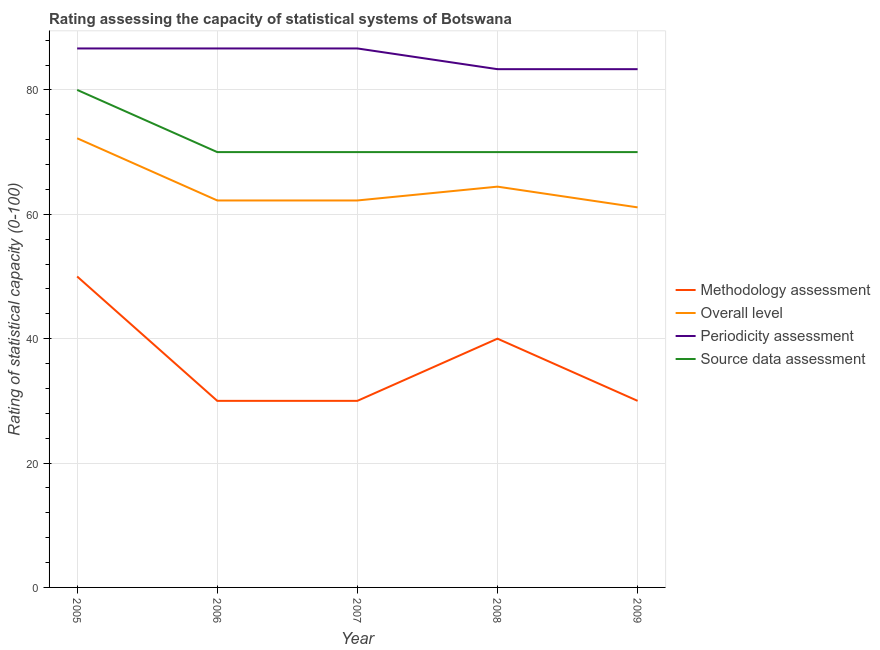Is the number of lines equal to the number of legend labels?
Your response must be concise. Yes. What is the source data assessment rating in 2008?
Give a very brief answer. 70. Across all years, what is the maximum overall level rating?
Your response must be concise. 72.22. Across all years, what is the minimum source data assessment rating?
Your answer should be compact. 70. In which year was the methodology assessment rating maximum?
Offer a terse response. 2005. In which year was the periodicity assessment rating minimum?
Keep it short and to the point. 2008. What is the total methodology assessment rating in the graph?
Make the answer very short. 180. What is the difference between the overall level rating in 2007 and that in 2008?
Keep it short and to the point. -2.22. What is the difference between the periodicity assessment rating in 2007 and the overall level rating in 2008?
Provide a short and direct response. 22.22. What is the average periodicity assessment rating per year?
Ensure brevity in your answer.  85.33. In the year 2008, what is the difference between the overall level rating and periodicity assessment rating?
Your response must be concise. -18.89. What is the ratio of the overall level rating in 2007 to that in 2008?
Your answer should be compact. 0.97. Is the source data assessment rating in 2006 less than that in 2008?
Keep it short and to the point. No. What is the difference between the highest and the second highest overall level rating?
Your answer should be very brief. 7.78. What is the difference between the highest and the lowest overall level rating?
Your answer should be very brief. 11.11. Is the sum of the overall level rating in 2008 and 2009 greater than the maximum periodicity assessment rating across all years?
Your answer should be very brief. Yes. Is it the case that in every year, the sum of the overall level rating and source data assessment rating is greater than the sum of methodology assessment rating and periodicity assessment rating?
Offer a very short reply. No. Is it the case that in every year, the sum of the methodology assessment rating and overall level rating is greater than the periodicity assessment rating?
Provide a succinct answer. Yes. How many years are there in the graph?
Provide a succinct answer. 5. What is the difference between two consecutive major ticks on the Y-axis?
Keep it short and to the point. 20. Are the values on the major ticks of Y-axis written in scientific E-notation?
Provide a succinct answer. No. Does the graph contain grids?
Offer a very short reply. Yes. Where does the legend appear in the graph?
Your answer should be very brief. Center right. How are the legend labels stacked?
Your answer should be compact. Vertical. What is the title of the graph?
Keep it short and to the point. Rating assessing the capacity of statistical systems of Botswana. What is the label or title of the Y-axis?
Your answer should be very brief. Rating of statistical capacity (0-100). What is the Rating of statistical capacity (0-100) in Methodology assessment in 2005?
Give a very brief answer. 50. What is the Rating of statistical capacity (0-100) of Overall level in 2005?
Your answer should be compact. 72.22. What is the Rating of statistical capacity (0-100) of Periodicity assessment in 2005?
Make the answer very short. 86.67. What is the Rating of statistical capacity (0-100) in Methodology assessment in 2006?
Provide a short and direct response. 30. What is the Rating of statistical capacity (0-100) in Overall level in 2006?
Your answer should be compact. 62.22. What is the Rating of statistical capacity (0-100) in Periodicity assessment in 2006?
Offer a very short reply. 86.67. What is the Rating of statistical capacity (0-100) of Methodology assessment in 2007?
Give a very brief answer. 30. What is the Rating of statistical capacity (0-100) of Overall level in 2007?
Provide a succinct answer. 62.22. What is the Rating of statistical capacity (0-100) in Periodicity assessment in 2007?
Provide a succinct answer. 86.67. What is the Rating of statistical capacity (0-100) in Source data assessment in 2007?
Provide a succinct answer. 70. What is the Rating of statistical capacity (0-100) in Overall level in 2008?
Keep it short and to the point. 64.44. What is the Rating of statistical capacity (0-100) in Periodicity assessment in 2008?
Offer a very short reply. 83.33. What is the Rating of statistical capacity (0-100) in Overall level in 2009?
Keep it short and to the point. 61.11. What is the Rating of statistical capacity (0-100) in Periodicity assessment in 2009?
Provide a short and direct response. 83.33. Across all years, what is the maximum Rating of statistical capacity (0-100) in Overall level?
Give a very brief answer. 72.22. Across all years, what is the maximum Rating of statistical capacity (0-100) of Periodicity assessment?
Provide a succinct answer. 86.67. Across all years, what is the maximum Rating of statistical capacity (0-100) in Source data assessment?
Make the answer very short. 80. Across all years, what is the minimum Rating of statistical capacity (0-100) of Overall level?
Offer a very short reply. 61.11. Across all years, what is the minimum Rating of statistical capacity (0-100) in Periodicity assessment?
Provide a succinct answer. 83.33. Across all years, what is the minimum Rating of statistical capacity (0-100) of Source data assessment?
Provide a short and direct response. 70. What is the total Rating of statistical capacity (0-100) in Methodology assessment in the graph?
Give a very brief answer. 180. What is the total Rating of statistical capacity (0-100) in Overall level in the graph?
Your answer should be compact. 322.22. What is the total Rating of statistical capacity (0-100) in Periodicity assessment in the graph?
Offer a terse response. 426.67. What is the total Rating of statistical capacity (0-100) of Source data assessment in the graph?
Keep it short and to the point. 360. What is the difference between the Rating of statistical capacity (0-100) of Overall level in 2005 and that in 2006?
Ensure brevity in your answer.  10. What is the difference between the Rating of statistical capacity (0-100) in Periodicity assessment in 2005 and that in 2006?
Ensure brevity in your answer.  0. What is the difference between the Rating of statistical capacity (0-100) of Periodicity assessment in 2005 and that in 2007?
Keep it short and to the point. 0. What is the difference between the Rating of statistical capacity (0-100) of Source data assessment in 2005 and that in 2007?
Your answer should be compact. 10. What is the difference between the Rating of statistical capacity (0-100) of Overall level in 2005 and that in 2008?
Your answer should be compact. 7.78. What is the difference between the Rating of statistical capacity (0-100) of Periodicity assessment in 2005 and that in 2008?
Make the answer very short. 3.33. What is the difference between the Rating of statistical capacity (0-100) in Source data assessment in 2005 and that in 2008?
Ensure brevity in your answer.  10. What is the difference between the Rating of statistical capacity (0-100) of Methodology assessment in 2005 and that in 2009?
Your response must be concise. 20. What is the difference between the Rating of statistical capacity (0-100) of Overall level in 2005 and that in 2009?
Make the answer very short. 11.11. What is the difference between the Rating of statistical capacity (0-100) of Periodicity assessment in 2005 and that in 2009?
Make the answer very short. 3.33. What is the difference between the Rating of statistical capacity (0-100) in Source data assessment in 2006 and that in 2007?
Make the answer very short. 0. What is the difference between the Rating of statistical capacity (0-100) in Overall level in 2006 and that in 2008?
Your answer should be very brief. -2.22. What is the difference between the Rating of statistical capacity (0-100) of Periodicity assessment in 2006 and that in 2008?
Your response must be concise. 3.33. What is the difference between the Rating of statistical capacity (0-100) of Source data assessment in 2006 and that in 2008?
Provide a succinct answer. 0. What is the difference between the Rating of statistical capacity (0-100) of Methodology assessment in 2006 and that in 2009?
Offer a terse response. 0. What is the difference between the Rating of statistical capacity (0-100) of Overall level in 2006 and that in 2009?
Keep it short and to the point. 1.11. What is the difference between the Rating of statistical capacity (0-100) in Periodicity assessment in 2006 and that in 2009?
Keep it short and to the point. 3.33. What is the difference between the Rating of statistical capacity (0-100) in Overall level in 2007 and that in 2008?
Your response must be concise. -2.22. What is the difference between the Rating of statistical capacity (0-100) of Source data assessment in 2007 and that in 2008?
Offer a terse response. 0. What is the difference between the Rating of statistical capacity (0-100) in Methodology assessment in 2007 and that in 2009?
Give a very brief answer. 0. What is the difference between the Rating of statistical capacity (0-100) of Periodicity assessment in 2007 and that in 2009?
Keep it short and to the point. 3.33. What is the difference between the Rating of statistical capacity (0-100) of Methodology assessment in 2008 and that in 2009?
Keep it short and to the point. 10. What is the difference between the Rating of statistical capacity (0-100) of Methodology assessment in 2005 and the Rating of statistical capacity (0-100) of Overall level in 2006?
Give a very brief answer. -12.22. What is the difference between the Rating of statistical capacity (0-100) of Methodology assessment in 2005 and the Rating of statistical capacity (0-100) of Periodicity assessment in 2006?
Keep it short and to the point. -36.67. What is the difference between the Rating of statistical capacity (0-100) in Overall level in 2005 and the Rating of statistical capacity (0-100) in Periodicity assessment in 2006?
Offer a terse response. -14.44. What is the difference between the Rating of statistical capacity (0-100) in Overall level in 2005 and the Rating of statistical capacity (0-100) in Source data assessment in 2006?
Give a very brief answer. 2.22. What is the difference between the Rating of statistical capacity (0-100) of Periodicity assessment in 2005 and the Rating of statistical capacity (0-100) of Source data assessment in 2006?
Offer a terse response. 16.67. What is the difference between the Rating of statistical capacity (0-100) in Methodology assessment in 2005 and the Rating of statistical capacity (0-100) in Overall level in 2007?
Your answer should be very brief. -12.22. What is the difference between the Rating of statistical capacity (0-100) of Methodology assessment in 2005 and the Rating of statistical capacity (0-100) of Periodicity assessment in 2007?
Your answer should be compact. -36.67. What is the difference between the Rating of statistical capacity (0-100) of Overall level in 2005 and the Rating of statistical capacity (0-100) of Periodicity assessment in 2007?
Your response must be concise. -14.44. What is the difference between the Rating of statistical capacity (0-100) in Overall level in 2005 and the Rating of statistical capacity (0-100) in Source data assessment in 2007?
Give a very brief answer. 2.22. What is the difference between the Rating of statistical capacity (0-100) in Periodicity assessment in 2005 and the Rating of statistical capacity (0-100) in Source data assessment in 2007?
Make the answer very short. 16.67. What is the difference between the Rating of statistical capacity (0-100) of Methodology assessment in 2005 and the Rating of statistical capacity (0-100) of Overall level in 2008?
Offer a very short reply. -14.44. What is the difference between the Rating of statistical capacity (0-100) in Methodology assessment in 2005 and the Rating of statistical capacity (0-100) in Periodicity assessment in 2008?
Provide a short and direct response. -33.33. What is the difference between the Rating of statistical capacity (0-100) in Methodology assessment in 2005 and the Rating of statistical capacity (0-100) in Source data assessment in 2008?
Keep it short and to the point. -20. What is the difference between the Rating of statistical capacity (0-100) in Overall level in 2005 and the Rating of statistical capacity (0-100) in Periodicity assessment in 2008?
Provide a short and direct response. -11.11. What is the difference between the Rating of statistical capacity (0-100) in Overall level in 2005 and the Rating of statistical capacity (0-100) in Source data assessment in 2008?
Provide a succinct answer. 2.22. What is the difference between the Rating of statistical capacity (0-100) of Periodicity assessment in 2005 and the Rating of statistical capacity (0-100) of Source data assessment in 2008?
Provide a succinct answer. 16.67. What is the difference between the Rating of statistical capacity (0-100) in Methodology assessment in 2005 and the Rating of statistical capacity (0-100) in Overall level in 2009?
Your answer should be compact. -11.11. What is the difference between the Rating of statistical capacity (0-100) of Methodology assessment in 2005 and the Rating of statistical capacity (0-100) of Periodicity assessment in 2009?
Offer a terse response. -33.33. What is the difference between the Rating of statistical capacity (0-100) of Methodology assessment in 2005 and the Rating of statistical capacity (0-100) of Source data assessment in 2009?
Give a very brief answer. -20. What is the difference between the Rating of statistical capacity (0-100) of Overall level in 2005 and the Rating of statistical capacity (0-100) of Periodicity assessment in 2009?
Provide a succinct answer. -11.11. What is the difference between the Rating of statistical capacity (0-100) of Overall level in 2005 and the Rating of statistical capacity (0-100) of Source data assessment in 2009?
Make the answer very short. 2.22. What is the difference between the Rating of statistical capacity (0-100) in Periodicity assessment in 2005 and the Rating of statistical capacity (0-100) in Source data assessment in 2009?
Make the answer very short. 16.67. What is the difference between the Rating of statistical capacity (0-100) of Methodology assessment in 2006 and the Rating of statistical capacity (0-100) of Overall level in 2007?
Ensure brevity in your answer.  -32.22. What is the difference between the Rating of statistical capacity (0-100) in Methodology assessment in 2006 and the Rating of statistical capacity (0-100) in Periodicity assessment in 2007?
Your response must be concise. -56.67. What is the difference between the Rating of statistical capacity (0-100) in Overall level in 2006 and the Rating of statistical capacity (0-100) in Periodicity assessment in 2007?
Offer a very short reply. -24.44. What is the difference between the Rating of statistical capacity (0-100) in Overall level in 2006 and the Rating of statistical capacity (0-100) in Source data assessment in 2007?
Your answer should be compact. -7.78. What is the difference between the Rating of statistical capacity (0-100) of Periodicity assessment in 2006 and the Rating of statistical capacity (0-100) of Source data assessment in 2007?
Make the answer very short. 16.67. What is the difference between the Rating of statistical capacity (0-100) in Methodology assessment in 2006 and the Rating of statistical capacity (0-100) in Overall level in 2008?
Your response must be concise. -34.44. What is the difference between the Rating of statistical capacity (0-100) of Methodology assessment in 2006 and the Rating of statistical capacity (0-100) of Periodicity assessment in 2008?
Ensure brevity in your answer.  -53.33. What is the difference between the Rating of statistical capacity (0-100) of Methodology assessment in 2006 and the Rating of statistical capacity (0-100) of Source data assessment in 2008?
Provide a succinct answer. -40. What is the difference between the Rating of statistical capacity (0-100) of Overall level in 2006 and the Rating of statistical capacity (0-100) of Periodicity assessment in 2008?
Offer a very short reply. -21.11. What is the difference between the Rating of statistical capacity (0-100) in Overall level in 2006 and the Rating of statistical capacity (0-100) in Source data assessment in 2008?
Provide a short and direct response. -7.78. What is the difference between the Rating of statistical capacity (0-100) of Periodicity assessment in 2006 and the Rating of statistical capacity (0-100) of Source data assessment in 2008?
Offer a terse response. 16.67. What is the difference between the Rating of statistical capacity (0-100) of Methodology assessment in 2006 and the Rating of statistical capacity (0-100) of Overall level in 2009?
Provide a short and direct response. -31.11. What is the difference between the Rating of statistical capacity (0-100) of Methodology assessment in 2006 and the Rating of statistical capacity (0-100) of Periodicity assessment in 2009?
Ensure brevity in your answer.  -53.33. What is the difference between the Rating of statistical capacity (0-100) of Methodology assessment in 2006 and the Rating of statistical capacity (0-100) of Source data assessment in 2009?
Provide a succinct answer. -40. What is the difference between the Rating of statistical capacity (0-100) of Overall level in 2006 and the Rating of statistical capacity (0-100) of Periodicity assessment in 2009?
Provide a short and direct response. -21.11. What is the difference between the Rating of statistical capacity (0-100) in Overall level in 2006 and the Rating of statistical capacity (0-100) in Source data assessment in 2009?
Your answer should be very brief. -7.78. What is the difference between the Rating of statistical capacity (0-100) of Periodicity assessment in 2006 and the Rating of statistical capacity (0-100) of Source data assessment in 2009?
Provide a short and direct response. 16.67. What is the difference between the Rating of statistical capacity (0-100) in Methodology assessment in 2007 and the Rating of statistical capacity (0-100) in Overall level in 2008?
Offer a terse response. -34.44. What is the difference between the Rating of statistical capacity (0-100) in Methodology assessment in 2007 and the Rating of statistical capacity (0-100) in Periodicity assessment in 2008?
Give a very brief answer. -53.33. What is the difference between the Rating of statistical capacity (0-100) of Overall level in 2007 and the Rating of statistical capacity (0-100) of Periodicity assessment in 2008?
Your answer should be compact. -21.11. What is the difference between the Rating of statistical capacity (0-100) in Overall level in 2007 and the Rating of statistical capacity (0-100) in Source data assessment in 2008?
Provide a succinct answer. -7.78. What is the difference between the Rating of statistical capacity (0-100) in Periodicity assessment in 2007 and the Rating of statistical capacity (0-100) in Source data assessment in 2008?
Keep it short and to the point. 16.67. What is the difference between the Rating of statistical capacity (0-100) of Methodology assessment in 2007 and the Rating of statistical capacity (0-100) of Overall level in 2009?
Your response must be concise. -31.11. What is the difference between the Rating of statistical capacity (0-100) of Methodology assessment in 2007 and the Rating of statistical capacity (0-100) of Periodicity assessment in 2009?
Your answer should be compact. -53.33. What is the difference between the Rating of statistical capacity (0-100) in Overall level in 2007 and the Rating of statistical capacity (0-100) in Periodicity assessment in 2009?
Provide a short and direct response. -21.11. What is the difference between the Rating of statistical capacity (0-100) of Overall level in 2007 and the Rating of statistical capacity (0-100) of Source data assessment in 2009?
Keep it short and to the point. -7.78. What is the difference between the Rating of statistical capacity (0-100) of Periodicity assessment in 2007 and the Rating of statistical capacity (0-100) of Source data assessment in 2009?
Provide a succinct answer. 16.67. What is the difference between the Rating of statistical capacity (0-100) in Methodology assessment in 2008 and the Rating of statistical capacity (0-100) in Overall level in 2009?
Provide a succinct answer. -21.11. What is the difference between the Rating of statistical capacity (0-100) of Methodology assessment in 2008 and the Rating of statistical capacity (0-100) of Periodicity assessment in 2009?
Keep it short and to the point. -43.33. What is the difference between the Rating of statistical capacity (0-100) in Overall level in 2008 and the Rating of statistical capacity (0-100) in Periodicity assessment in 2009?
Give a very brief answer. -18.89. What is the difference between the Rating of statistical capacity (0-100) in Overall level in 2008 and the Rating of statistical capacity (0-100) in Source data assessment in 2009?
Your answer should be very brief. -5.56. What is the difference between the Rating of statistical capacity (0-100) of Periodicity assessment in 2008 and the Rating of statistical capacity (0-100) of Source data assessment in 2009?
Provide a succinct answer. 13.33. What is the average Rating of statistical capacity (0-100) of Methodology assessment per year?
Your response must be concise. 36. What is the average Rating of statistical capacity (0-100) in Overall level per year?
Give a very brief answer. 64.44. What is the average Rating of statistical capacity (0-100) of Periodicity assessment per year?
Provide a succinct answer. 85.33. What is the average Rating of statistical capacity (0-100) of Source data assessment per year?
Your response must be concise. 72. In the year 2005, what is the difference between the Rating of statistical capacity (0-100) of Methodology assessment and Rating of statistical capacity (0-100) of Overall level?
Your answer should be very brief. -22.22. In the year 2005, what is the difference between the Rating of statistical capacity (0-100) of Methodology assessment and Rating of statistical capacity (0-100) of Periodicity assessment?
Ensure brevity in your answer.  -36.67. In the year 2005, what is the difference between the Rating of statistical capacity (0-100) of Methodology assessment and Rating of statistical capacity (0-100) of Source data assessment?
Ensure brevity in your answer.  -30. In the year 2005, what is the difference between the Rating of statistical capacity (0-100) of Overall level and Rating of statistical capacity (0-100) of Periodicity assessment?
Ensure brevity in your answer.  -14.44. In the year 2005, what is the difference between the Rating of statistical capacity (0-100) in Overall level and Rating of statistical capacity (0-100) in Source data assessment?
Provide a succinct answer. -7.78. In the year 2006, what is the difference between the Rating of statistical capacity (0-100) of Methodology assessment and Rating of statistical capacity (0-100) of Overall level?
Your answer should be very brief. -32.22. In the year 2006, what is the difference between the Rating of statistical capacity (0-100) in Methodology assessment and Rating of statistical capacity (0-100) in Periodicity assessment?
Your answer should be compact. -56.67. In the year 2006, what is the difference between the Rating of statistical capacity (0-100) in Overall level and Rating of statistical capacity (0-100) in Periodicity assessment?
Ensure brevity in your answer.  -24.44. In the year 2006, what is the difference between the Rating of statistical capacity (0-100) in Overall level and Rating of statistical capacity (0-100) in Source data assessment?
Your response must be concise. -7.78. In the year 2006, what is the difference between the Rating of statistical capacity (0-100) in Periodicity assessment and Rating of statistical capacity (0-100) in Source data assessment?
Make the answer very short. 16.67. In the year 2007, what is the difference between the Rating of statistical capacity (0-100) in Methodology assessment and Rating of statistical capacity (0-100) in Overall level?
Your answer should be very brief. -32.22. In the year 2007, what is the difference between the Rating of statistical capacity (0-100) of Methodology assessment and Rating of statistical capacity (0-100) of Periodicity assessment?
Provide a short and direct response. -56.67. In the year 2007, what is the difference between the Rating of statistical capacity (0-100) in Methodology assessment and Rating of statistical capacity (0-100) in Source data assessment?
Offer a very short reply. -40. In the year 2007, what is the difference between the Rating of statistical capacity (0-100) of Overall level and Rating of statistical capacity (0-100) of Periodicity assessment?
Provide a short and direct response. -24.44. In the year 2007, what is the difference between the Rating of statistical capacity (0-100) of Overall level and Rating of statistical capacity (0-100) of Source data assessment?
Offer a terse response. -7.78. In the year 2007, what is the difference between the Rating of statistical capacity (0-100) in Periodicity assessment and Rating of statistical capacity (0-100) in Source data assessment?
Make the answer very short. 16.67. In the year 2008, what is the difference between the Rating of statistical capacity (0-100) in Methodology assessment and Rating of statistical capacity (0-100) in Overall level?
Offer a terse response. -24.44. In the year 2008, what is the difference between the Rating of statistical capacity (0-100) in Methodology assessment and Rating of statistical capacity (0-100) in Periodicity assessment?
Provide a short and direct response. -43.33. In the year 2008, what is the difference between the Rating of statistical capacity (0-100) of Methodology assessment and Rating of statistical capacity (0-100) of Source data assessment?
Keep it short and to the point. -30. In the year 2008, what is the difference between the Rating of statistical capacity (0-100) of Overall level and Rating of statistical capacity (0-100) of Periodicity assessment?
Ensure brevity in your answer.  -18.89. In the year 2008, what is the difference between the Rating of statistical capacity (0-100) of Overall level and Rating of statistical capacity (0-100) of Source data assessment?
Ensure brevity in your answer.  -5.56. In the year 2008, what is the difference between the Rating of statistical capacity (0-100) of Periodicity assessment and Rating of statistical capacity (0-100) of Source data assessment?
Offer a terse response. 13.33. In the year 2009, what is the difference between the Rating of statistical capacity (0-100) of Methodology assessment and Rating of statistical capacity (0-100) of Overall level?
Provide a succinct answer. -31.11. In the year 2009, what is the difference between the Rating of statistical capacity (0-100) in Methodology assessment and Rating of statistical capacity (0-100) in Periodicity assessment?
Provide a succinct answer. -53.33. In the year 2009, what is the difference between the Rating of statistical capacity (0-100) in Methodology assessment and Rating of statistical capacity (0-100) in Source data assessment?
Offer a terse response. -40. In the year 2009, what is the difference between the Rating of statistical capacity (0-100) of Overall level and Rating of statistical capacity (0-100) of Periodicity assessment?
Provide a short and direct response. -22.22. In the year 2009, what is the difference between the Rating of statistical capacity (0-100) in Overall level and Rating of statistical capacity (0-100) in Source data assessment?
Offer a terse response. -8.89. In the year 2009, what is the difference between the Rating of statistical capacity (0-100) of Periodicity assessment and Rating of statistical capacity (0-100) of Source data assessment?
Your answer should be very brief. 13.33. What is the ratio of the Rating of statistical capacity (0-100) in Methodology assessment in 2005 to that in 2006?
Offer a very short reply. 1.67. What is the ratio of the Rating of statistical capacity (0-100) of Overall level in 2005 to that in 2006?
Provide a short and direct response. 1.16. What is the ratio of the Rating of statistical capacity (0-100) of Periodicity assessment in 2005 to that in 2006?
Provide a succinct answer. 1. What is the ratio of the Rating of statistical capacity (0-100) in Methodology assessment in 2005 to that in 2007?
Your answer should be compact. 1.67. What is the ratio of the Rating of statistical capacity (0-100) in Overall level in 2005 to that in 2007?
Make the answer very short. 1.16. What is the ratio of the Rating of statistical capacity (0-100) of Source data assessment in 2005 to that in 2007?
Your answer should be very brief. 1.14. What is the ratio of the Rating of statistical capacity (0-100) of Methodology assessment in 2005 to that in 2008?
Your answer should be very brief. 1.25. What is the ratio of the Rating of statistical capacity (0-100) of Overall level in 2005 to that in 2008?
Offer a very short reply. 1.12. What is the ratio of the Rating of statistical capacity (0-100) in Source data assessment in 2005 to that in 2008?
Offer a very short reply. 1.14. What is the ratio of the Rating of statistical capacity (0-100) of Methodology assessment in 2005 to that in 2009?
Offer a terse response. 1.67. What is the ratio of the Rating of statistical capacity (0-100) in Overall level in 2005 to that in 2009?
Make the answer very short. 1.18. What is the ratio of the Rating of statistical capacity (0-100) of Periodicity assessment in 2005 to that in 2009?
Offer a very short reply. 1.04. What is the ratio of the Rating of statistical capacity (0-100) in Source data assessment in 2005 to that in 2009?
Offer a terse response. 1.14. What is the ratio of the Rating of statistical capacity (0-100) of Methodology assessment in 2006 to that in 2007?
Your answer should be compact. 1. What is the ratio of the Rating of statistical capacity (0-100) in Overall level in 2006 to that in 2008?
Your answer should be compact. 0.97. What is the ratio of the Rating of statistical capacity (0-100) in Periodicity assessment in 2006 to that in 2008?
Keep it short and to the point. 1.04. What is the ratio of the Rating of statistical capacity (0-100) in Source data assessment in 2006 to that in 2008?
Your response must be concise. 1. What is the ratio of the Rating of statistical capacity (0-100) of Overall level in 2006 to that in 2009?
Provide a succinct answer. 1.02. What is the ratio of the Rating of statistical capacity (0-100) of Source data assessment in 2006 to that in 2009?
Give a very brief answer. 1. What is the ratio of the Rating of statistical capacity (0-100) in Methodology assessment in 2007 to that in 2008?
Your answer should be very brief. 0.75. What is the ratio of the Rating of statistical capacity (0-100) in Overall level in 2007 to that in 2008?
Give a very brief answer. 0.97. What is the ratio of the Rating of statistical capacity (0-100) in Periodicity assessment in 2007 to that in 2008?
Provide a short and direct response. 1.04. What is the ratio of the Rating of statistical capacity (0-100) of Overall level in 2007 to that in 2009?
Provide a short and direct response. 1.02. What is the ratio of the Rating of statistical capacity (0-100) in Source data assessment in 2007 to that in 2009?
Provide a short and direct response. 1. What is the ratio of the Rating of statistical capacity (0-100) of Methodology assessment in 2008 to that in 2009?
Offer a very short reply. 1.33. What is the ratio of the Rating of statistical capacity (0-100) of Overall level in 2008 to that in 2009?
Offer a terse response. 1.05. What is the ratio of the Rating of statistical capacity (0-100) of Periodicity assessment in 2008 to that in 2009?
Provide a short and direct response. 1. What is the difference between the highest and the second highest Rating of statistical capacity (0-100) in Methodology assessment?
Provide a succinct answer. 10. What is the difference between the highest and the second highest Rating of statistical capacity (0-100) of Overall level?
Offer a very short reply. 7.78. What is the difference between the highest and the lowest Rating of statistical capacity (0-100) of Methodology assessment?
Provide a short and direct response. 20. What is the difference between the highest and the lowest Rating of statistical capacity (0-100) in Overall level?
Your answer should be compact. 11.11. What is the difference between the highest and the lowest Rating of statistical capacity (0-100) of Source data assessment?
Your answer should be compact. 10. 